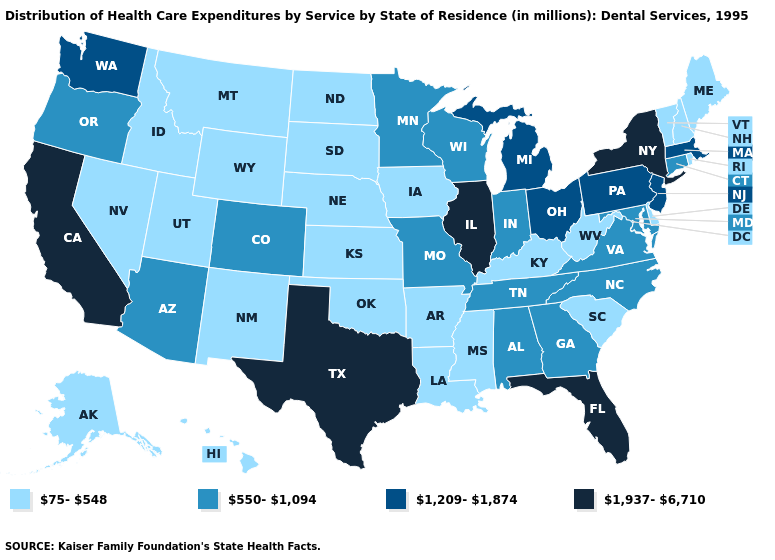What is the highest value in states that border Idaho?
Write a very short answer. 1,209-1,874. Which states have the lowest value in the West?
Be succinct. Alaska, Hawaii, Idaho, Montana, Nevada, New Mexico, Utah, Wyoming. Name the states that have a value in the range 75-548?
Quick response, please. Alaska, Arkansas, Delaware, Hawaii, Idaho, Iowa, Kansas, Kentucky, Louisiana, Maine, Mississippi, Montana, Nebraska, Nevada, New Hampshire, New Mexico, North Dakota, Oklahoma, Rhode Island, South Carolina, South Dakota, Utah, Vermont, West Virginia, Wyoming. Does South Dakota have the same value as Massachusetts?
Write a very short answer. No. What is the value of New Hampshire?
Keep it brief. 75-548. Which states have the highest value in the USA?
Write a very short answer. California, Florida, Illinois, New York, Texas. Name the states that have a value in the range 550-1,094?
Answer briefly. Alabama, Arizona, Colorado, Connecticut, Georgia, Indiana, Maryland, Minnesota, Missouri, North Carolina, Oregon, Tennessee, Virginia, Wisconsin. What is the value of Idaho?
Answer briefly. 75-548. Name the states that have a value in the range 1,937-6,710?
Short answer required. California, Florida, Illinois, New York, Texas. What is the value of South Dakota?
Concise answer only. 75-548. What is the value of Kansas?
Be succinct. 75-548. Among the states that border Michigan , does Indiana have the lowest value?
Give a very brief answer. Yes. Among the states that border Kansas , which have the lowest value?
Answer briefly. Nebraska, Oklahoma. Does the first symbol in the legend represent the smallest category?
Answer briefly. Yes. What is the value of New Mexico?
Short answer required. 75-548. 